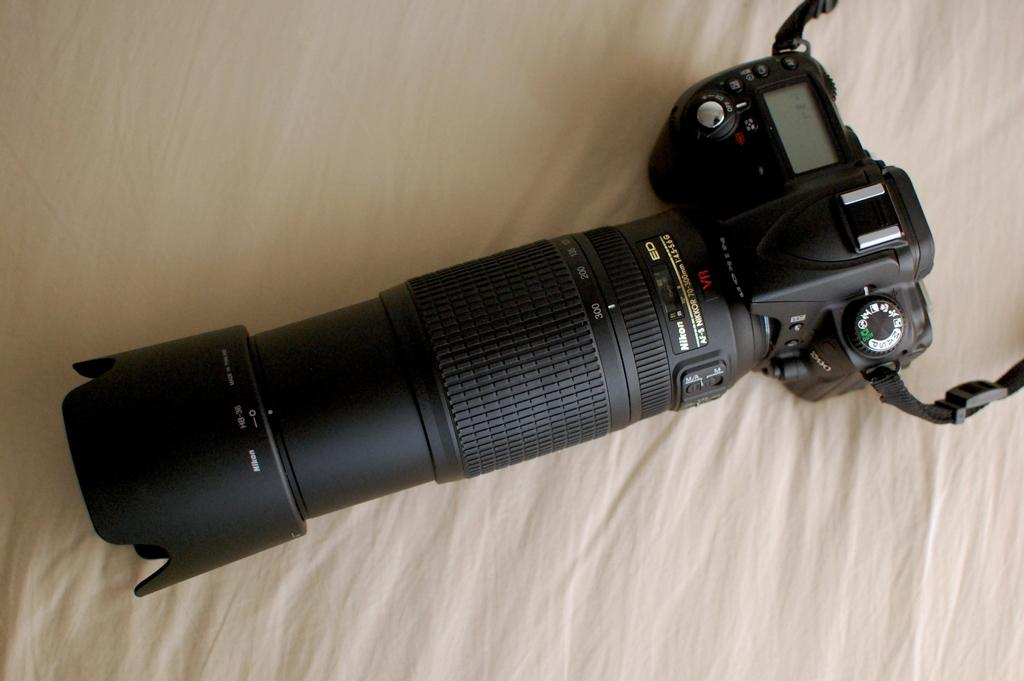What is the main object in the image? There is a camera in the image. Where is the camera placed? The camera is on a cloth. What type of harmony is being played by the camera in the image? There is no harmony being played in the image, as the camera is an inanimate object and cannot produce music. 